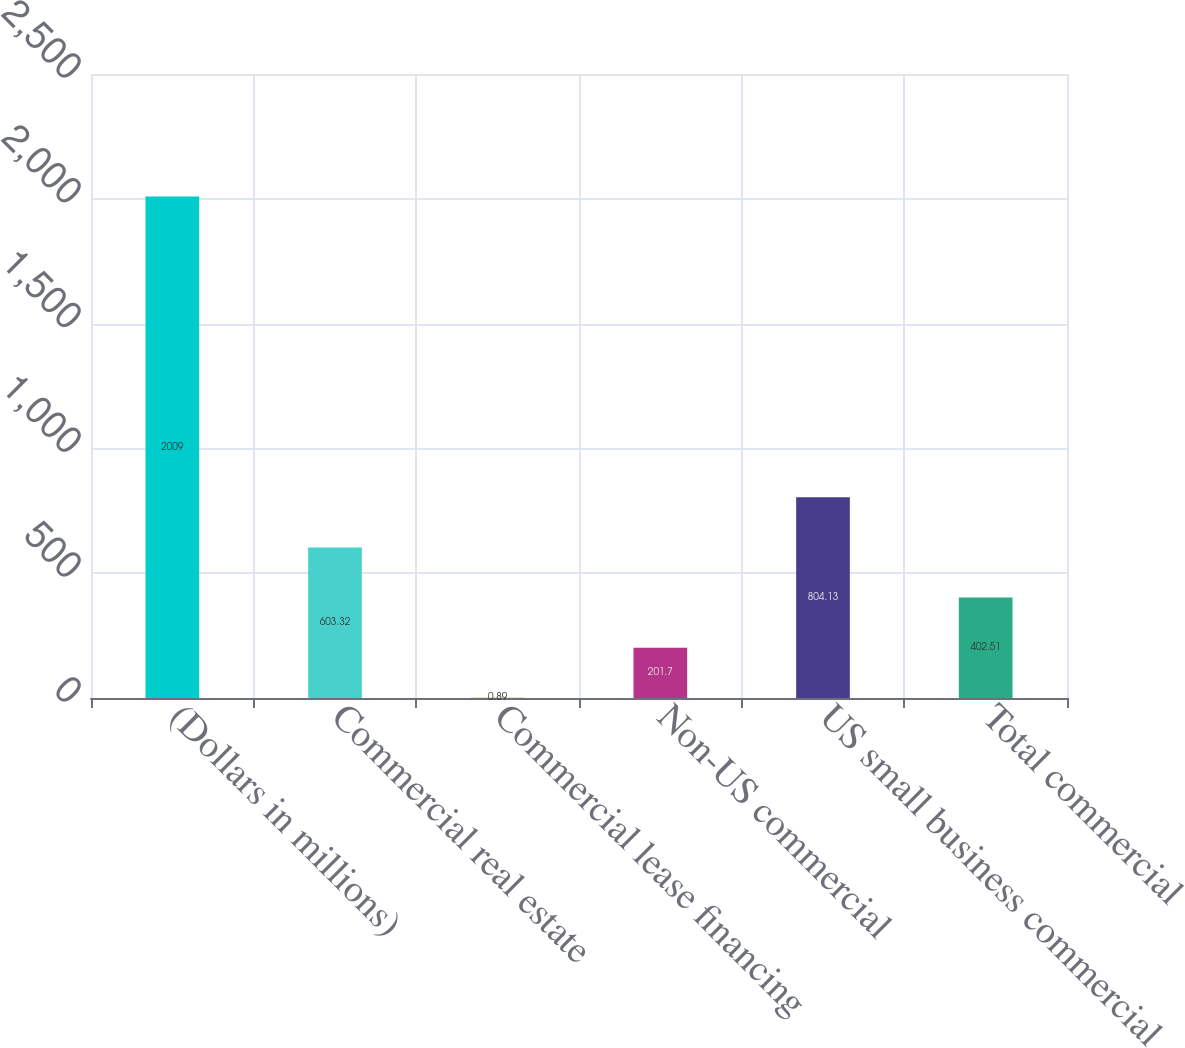Convert chart to OTSL. <chart><loc_0><loc_0><loc_500><loc_500><bar_chart><fcel>(Dollars in millions)<fcel>Commercial real estate<fcel>Commercial lease financing<fcel>Non-US commercial<fcel>US small business commercial<fcel>Total commercial<nl><fcel>2009<fcel>603.32<fcel>0.89<fcel>201.7<fcel>804.13<fcel>402.51<nl></chart> 